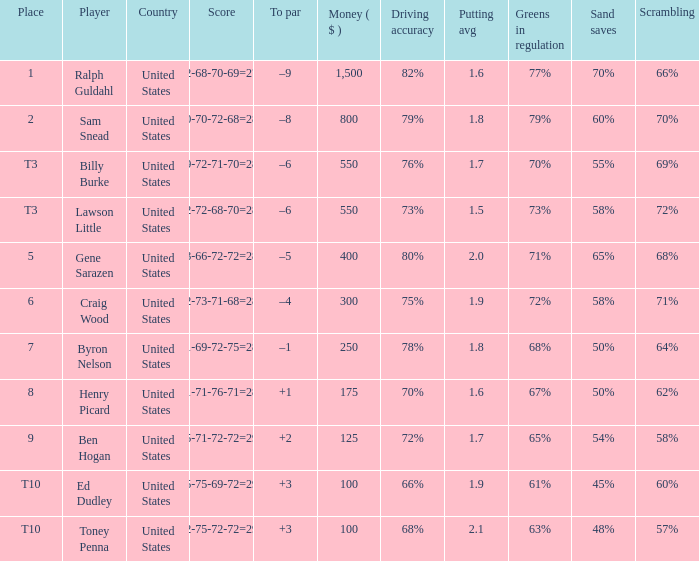Which score has a prize of $400? 73-66-72-72=283. 